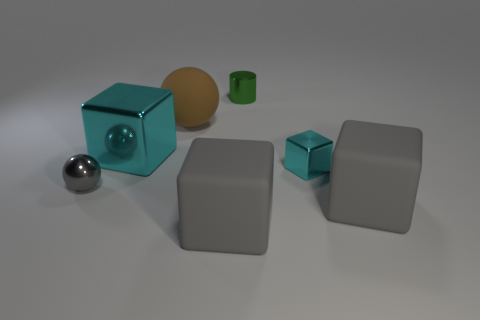Add 2 tiny metal cylinders. How many objects exist? 9 Subtract all cylinders. How many objects are left? 6 Subtract all tiny blue rubber blocks. Subtract all cyan cubes. How many objects are left? 5 Add 7 large brown matte things. How many large brown matte things are left? 8 Add 2 small yellow shiny spheres. How many small yellow shiny spheres exist? 2 Subtract 1 brown spheres. How many objects are left? 6 